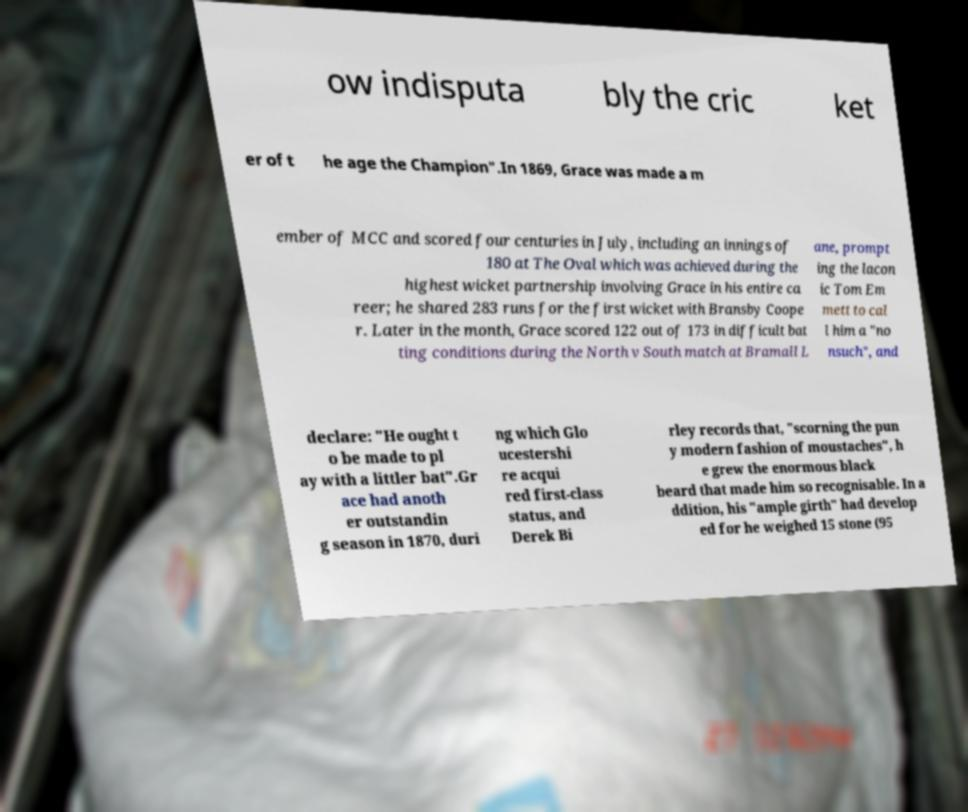Please identify and transcribe the text found in this image. ow indisputa bly the cric ket er of t he age the Champion".In 1869, Grace was made a m ember of MCC and scored four centuries in July, including an innings of 180 at The Oval which was achieved during the highest wicket partnership involving Grace in his entire ca reer; he shared 283 runs for the first wicket with Bransby Coope r. Later in the month, Grace scored 122 out of 173 in difficult bat ting conditions during the North v South match at Bramall L ane, prompt ing the lacon ic Tom Em mett to cal l him a "no nsuch", and declare: "He ought t o be made to pl ay with a littler bat".Gr ace had anoth er outstandin g season in 1870, duri ng which Glo ucestershi re acqui red first-class status, and Derek Bi rley records that, "scorning the pun y modern fashion of moustaches", h e grew the enormous black beard that made him so recognisable. In a ddition, his "ample girth" had develop ed for he weighed 15 stone (95 